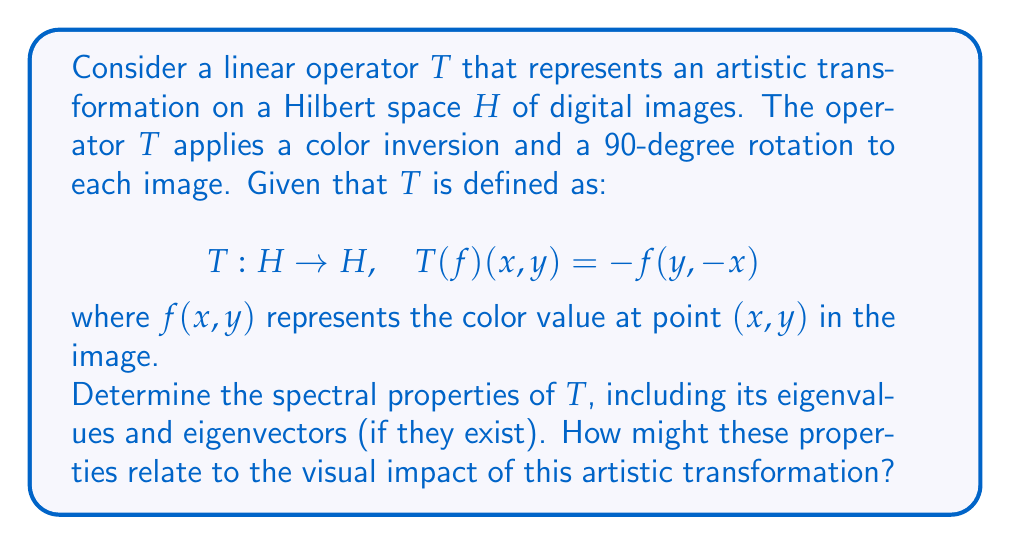Help me with this question. To determine the spectral properties of the linear operator $T$, we need to analyze its eigenvalues and eigenvectors. Let's approach this step-by-step:

1) First, let's consider the eigenvalue equation:
   $$T(f) = \lambda f$$

2) Expanding this using the definition of $T$:
   $$-f(y,-x) = \lambda f(x,y)$$

3) For this equation to hold, we must have:
   $$f(y,-x) = -\lambda f(x,y)$$

4) Applying $T$ again:
   $$T(T(f))(x,y) = -(-\lambda f(y,-x)) = \lambda^2 f(x,y)$$

5) This shows that $T^4 = I$, where $I$ is the identity operator. Therefore, the possible eigenvalues are the fourth roots of unity:
   $$\lambda = \pm 1, \pm i$$

6) For $\lambda = i$:
   $$f(y,-x) = -if(x,y)$$
   $$f(-x,-y) = -if(y,-x) = (-i)^2f(x,y) = -f(x,y)$$
   $$f(x,y) = if(-y,x)$$

7) This set of equations defines the eigenvectors for $\lambda = i$. Similar analysis can be done for the other eigenvalues.

8) The eigenvectors represent images that are invariant under the transformation, up to a scalar multiple. For example, eigenvectors corresponding to $\lambda = i$ are images that, when transformed by $T$, result in the same image rotated by 90° and color-inverted.

9) The spectrum of $T$ is the set of all eigenvalues: $\{\pm 1, \pm i\}$

10) Since $T$ is unitary (it preserves the norm of vectors), its spectrum lies on the unit circle in the complex plane.

Relating to visual arts: The eigenvalues and eigenvectors provide insight into the cyclical nature of this transformation. Applying $T$ four times returns the image to its original state, which could be used to create interesting rhythmic patterns or sequences in experimental digital art.
Answer: The spectral properties of $T$ are:
- Eigenvalues: $\{\pm 1, \pm i\}$
- Eigenvectors: Non-zero functions $f$ satisfying $f(y,-x) = -\lambda f(x,y)$ for each eigenvalue $\lambda$
- Spectrum: $\{\pm 1, \pm i\}$ (discrete spectrum on the unit circle) 